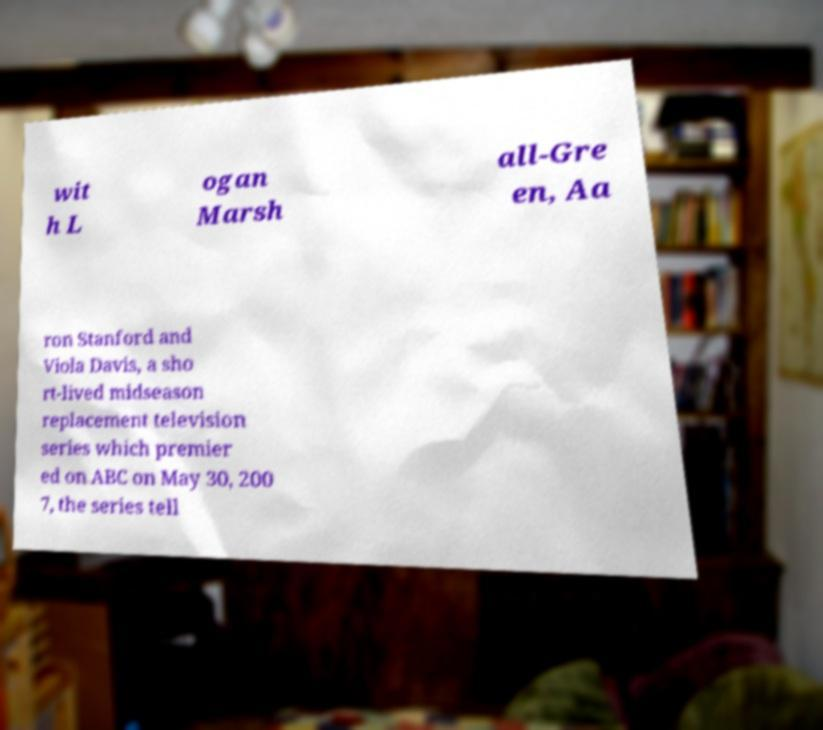Can you read and provide the text displayed in the image?This photo seems to have some interesting text. Can you extract and type it out for me? wit h L ogan Marsh all-Gre en, Aa ron Stanford and Viola Davis, a sho rt-lived midseason replacement television series which premier ed on ABC on May 30, 200 7, the series tell 